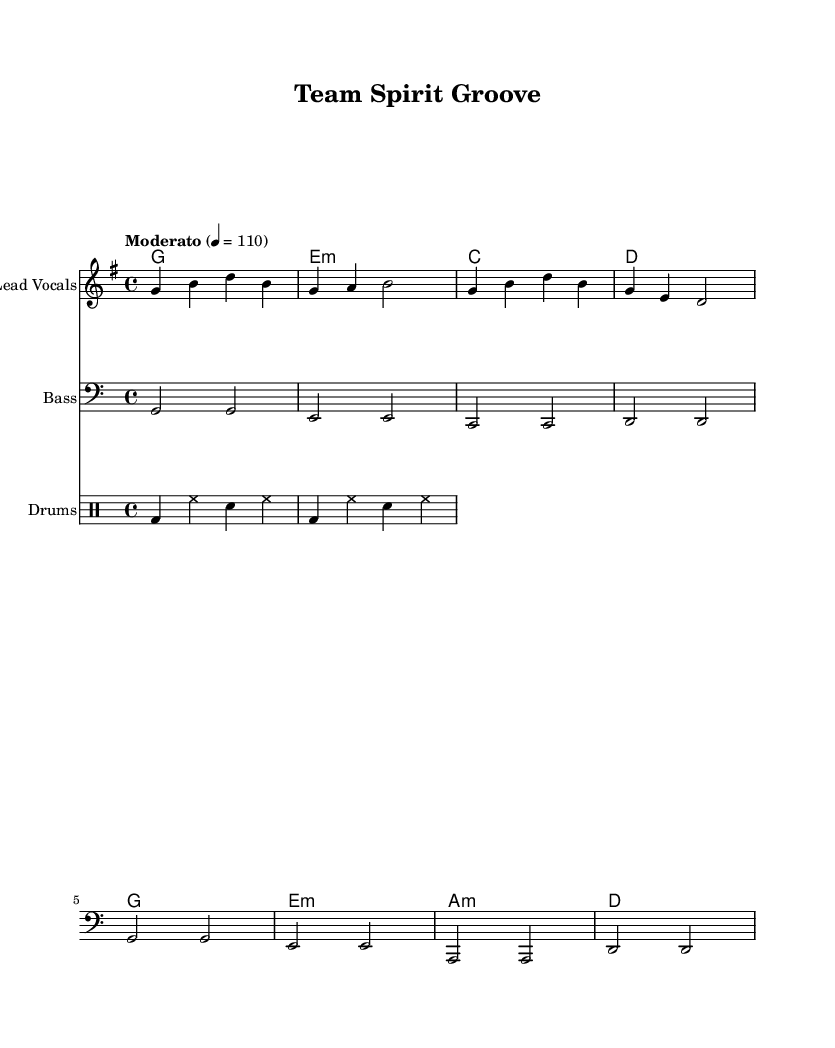What is the key signature of this music? The key signature is G major, which has one sharp (F#). You can identify the key signature by looking at the symbols at the beginning of the staff, just after the clef sign.
Answer: G major What is the time signature of the piece? The time signature is 4/4, indicated by the numbers at the beginning of the staff. This means there are four beats in each measure and the quarter note gets one beat.
Answer: 4/4 What is the tempo marking for this piece? The tempo marking is "Moderato," which indicates a moderate speed, along with the metronome marking of 110 beats per minute. This is found near the beginning of the score.
Answer: Moderato How many bars are there in the melody section? The melody section contains eight bars, as indicated by the number of complete measures in the melody part of the score. Counting the measures from start to finish will show that there are eight.
Answer: Eight What type of chords does the harmony section contain? The harmony section features triadic chords, which are built from three distinct notes. Analyzing the chord symbols in the harmony staff shows they are constructed as major and minor triads.
Answer: Triads Which lyrical theme does the song convey? The lyrics emphasize unity and team spirit, as seen in the text, "Together we stand, united we fall." The content of the lyrics directly reflects the motivational tone of rhythm and blues songs, which often focus on community and togetherness.
Answer: Unity What style of rhythm is primarily used in this piece? The rhythm style used is a driving groove, characterized by a consistent beat and syncopation common in Rhythm and Blues. Evaluating the drum pattern and its pattern of bass and snare hits shows this driving rhythm.
Answer: Driving groove 